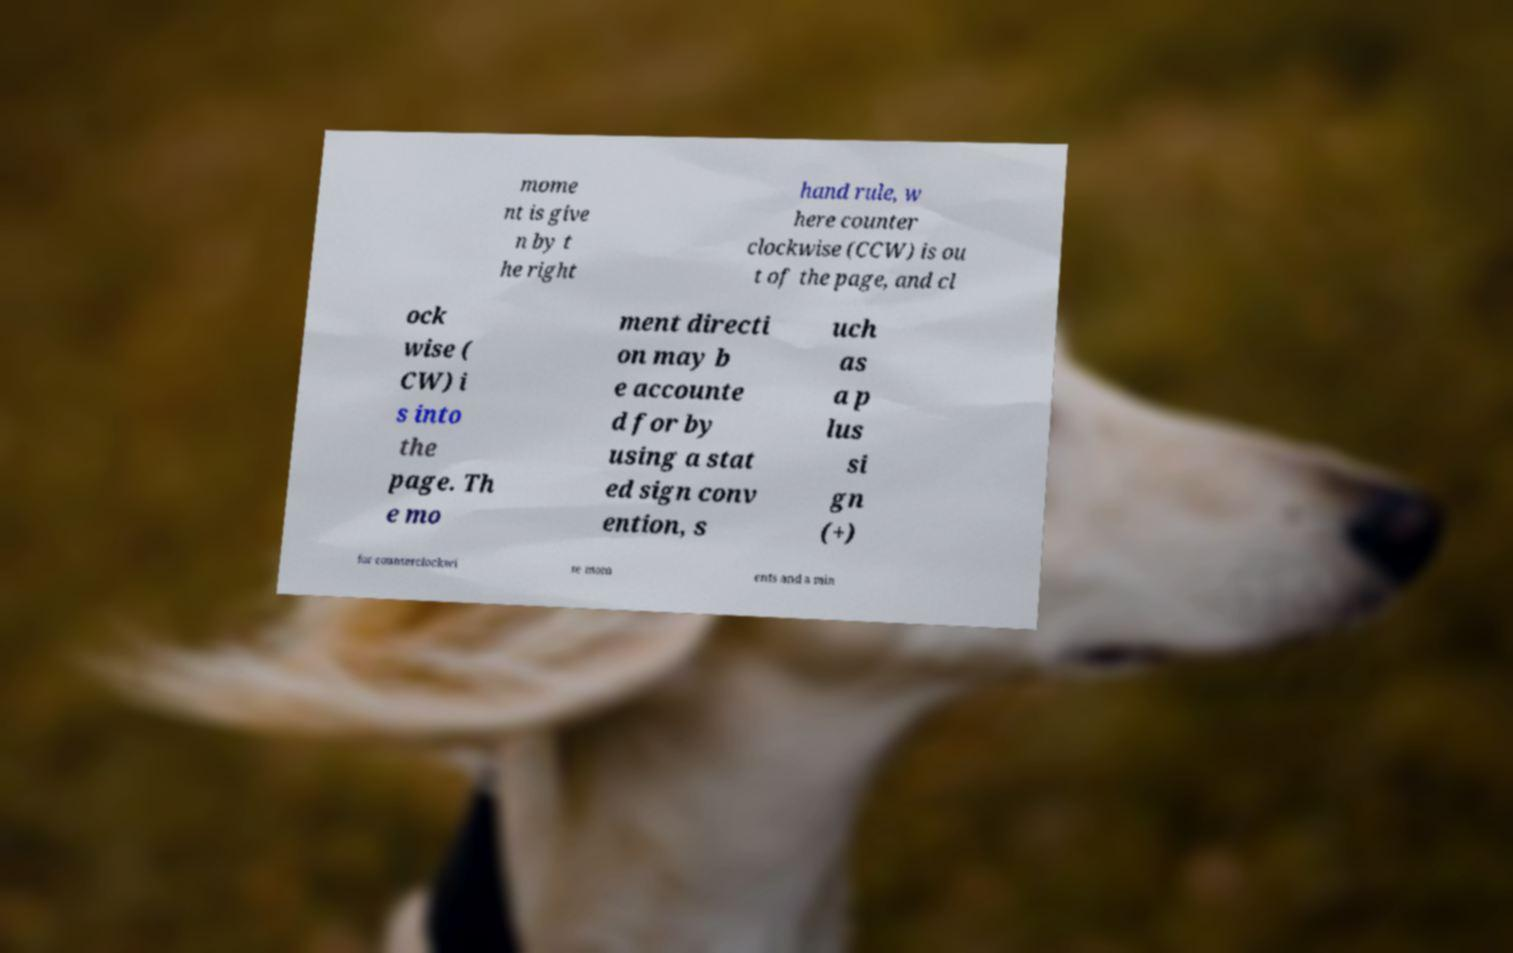There's text embedded in this image that I need extracted. Can you transcribe it verbatim? mome nt is give n by t he right hand rule, w here counter clockwise (CCW) is ou t of the page, and cl ock wise ( CW) i s into the page. Th e mo ment directi on may b e accounte d for by using a stat ed sign conv ention, s uch as a p lus si gn (+) for counterclockwi se mom ents and a min 